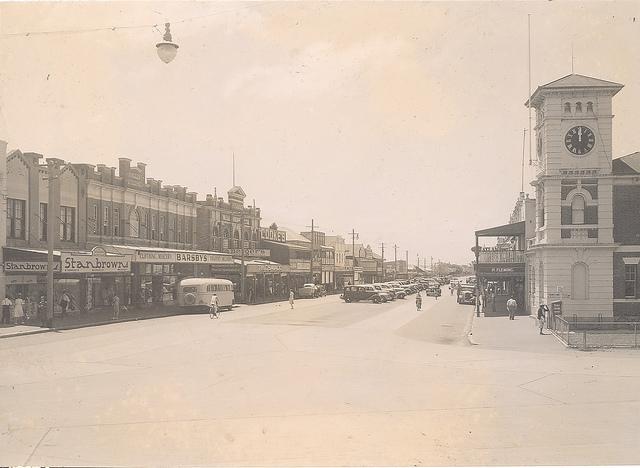What architectural style is visible in the background?
Give a very brief answer. American. What is hanging in the air?
Quick response, please. Street light. What season is this?
Short answer required. Summer. What time does the clock show?
Write a very short answer. 12:00. Is this a sunny scene?
Be succinct. Yes. What time does the clock have?
Be succinct. 12:00. 